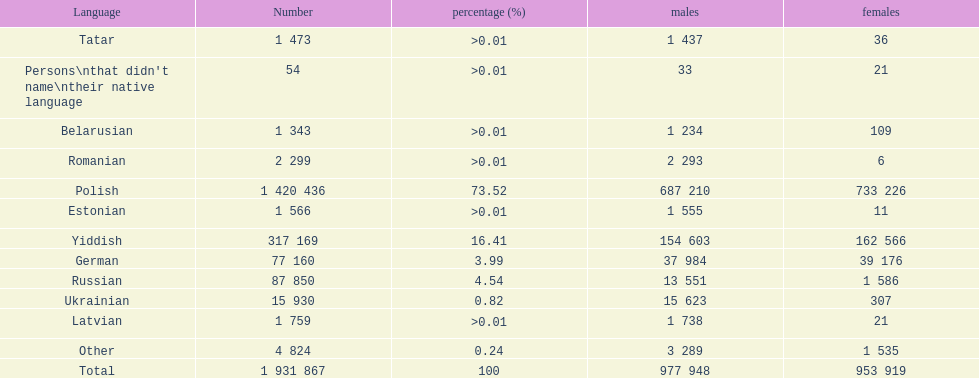Which language had the least female speakers? Romanian. 